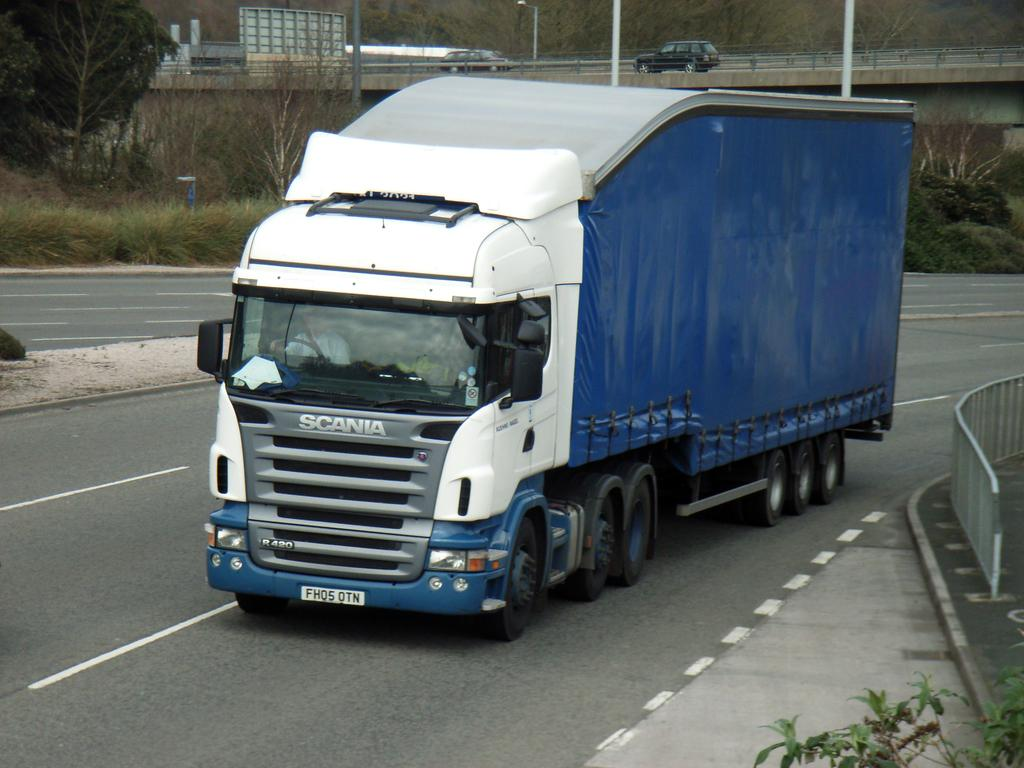What can be seen on the ground in the image? There are vehicles on the ground in the image. What type of barrier is present in the image? There is a fence in the image. What structure can be seen in the background of the image? There is a bridge in the background of the image. What type of natural elements are visible in the background of the image? Trees and plants are present in the background of the image. What else can be seen in the background of the image? There are poles in the background of the image. What punishment is the daughter receiving for misbehaving in the image? There is no daughter present in the image, nor is there any indication of punishment or misbehavior. 